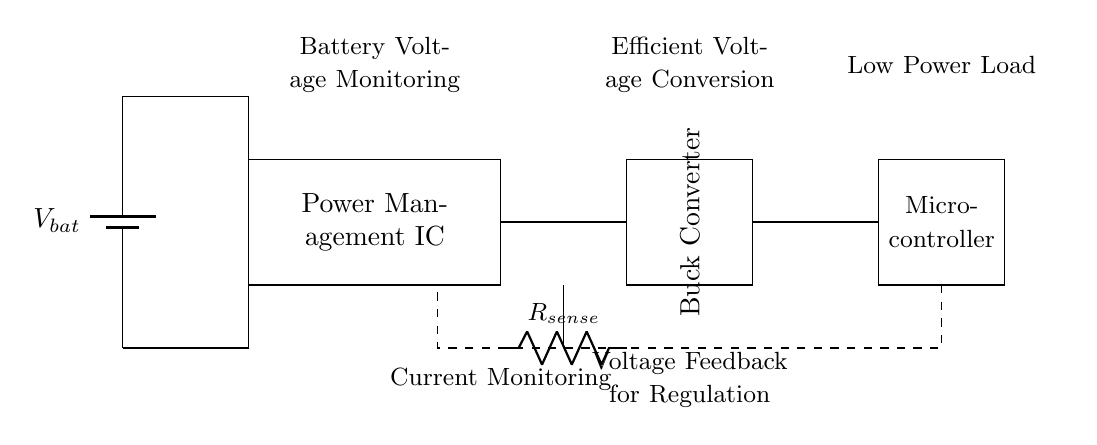What is the function of the power management IC? The power management IC is responsible for regulating voltage levels and ensuring efficient power delivery to the load, which in this case is the microcontroller.
Answer: Regulating voltage What type of converter is used in this circuit? The circuit uses a buck converter, as indicated by the "Buck Converter" label in the rectangle, which denotes its role in stepping down the voltage efficiently.
Answer: Buck converter What component is used for current sensing? The component used for current sensing is labeled as "R_sense" in the circuit, which is a resistor designed to measure the current flowing through the circuit.
Answer: Resistor What is the purpose of the dashed line in the circuit? The dashed line represents the voltage feedback path, which is crucial for regulating the output voltage from the buck converter back to the power management IC for stability.
Answer: Voltage feedback How does this circuit contribute to extending battery life? This circuit utilizes efficient voltage conversion and current monitoring to optimize power usage, which minimizes energy waste and extends battery life in portable devices.
Answer: Optimizing power usage What device does the circuit primarily power? The circuit primarily powers a microcontroller, as indicated by the label in the rectangular block towards the right of the diagram.
Answer: Microcontroller What is the voltage source labeled as in the circuit? The voltage source is labeled as "V_bat," which stands for the battery voltage supplying power to the circuit.
Answer: V_bat 